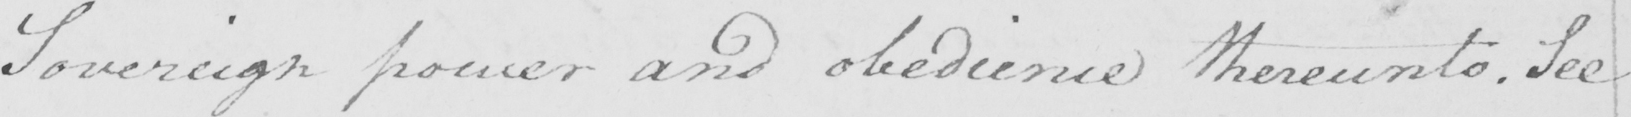Transcribe the text shown in this historical manuscript line. Sovereign power and obedience thereunto . See 